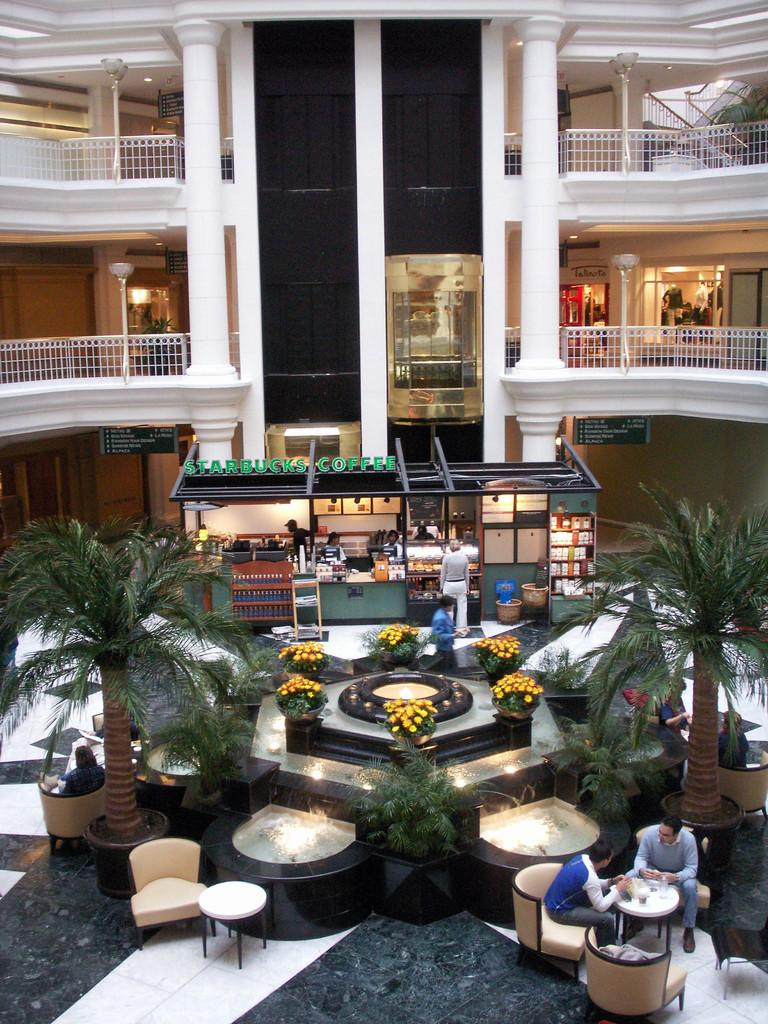<image>
Present a compact description of the photo's key features. The lobby of what appears to be a hotel with a Starbucks 